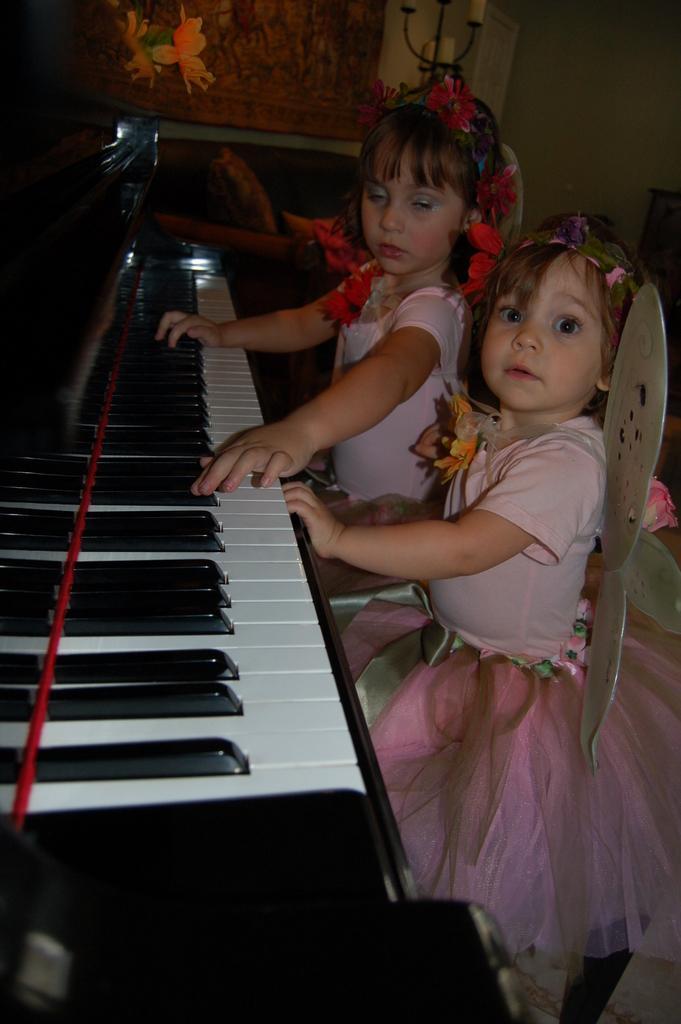How would you summarize this image in a sentence or two? There are two girls wearing angel dresses. One girl wearing is playing a piano. In the background there is a painting of a flowers. 